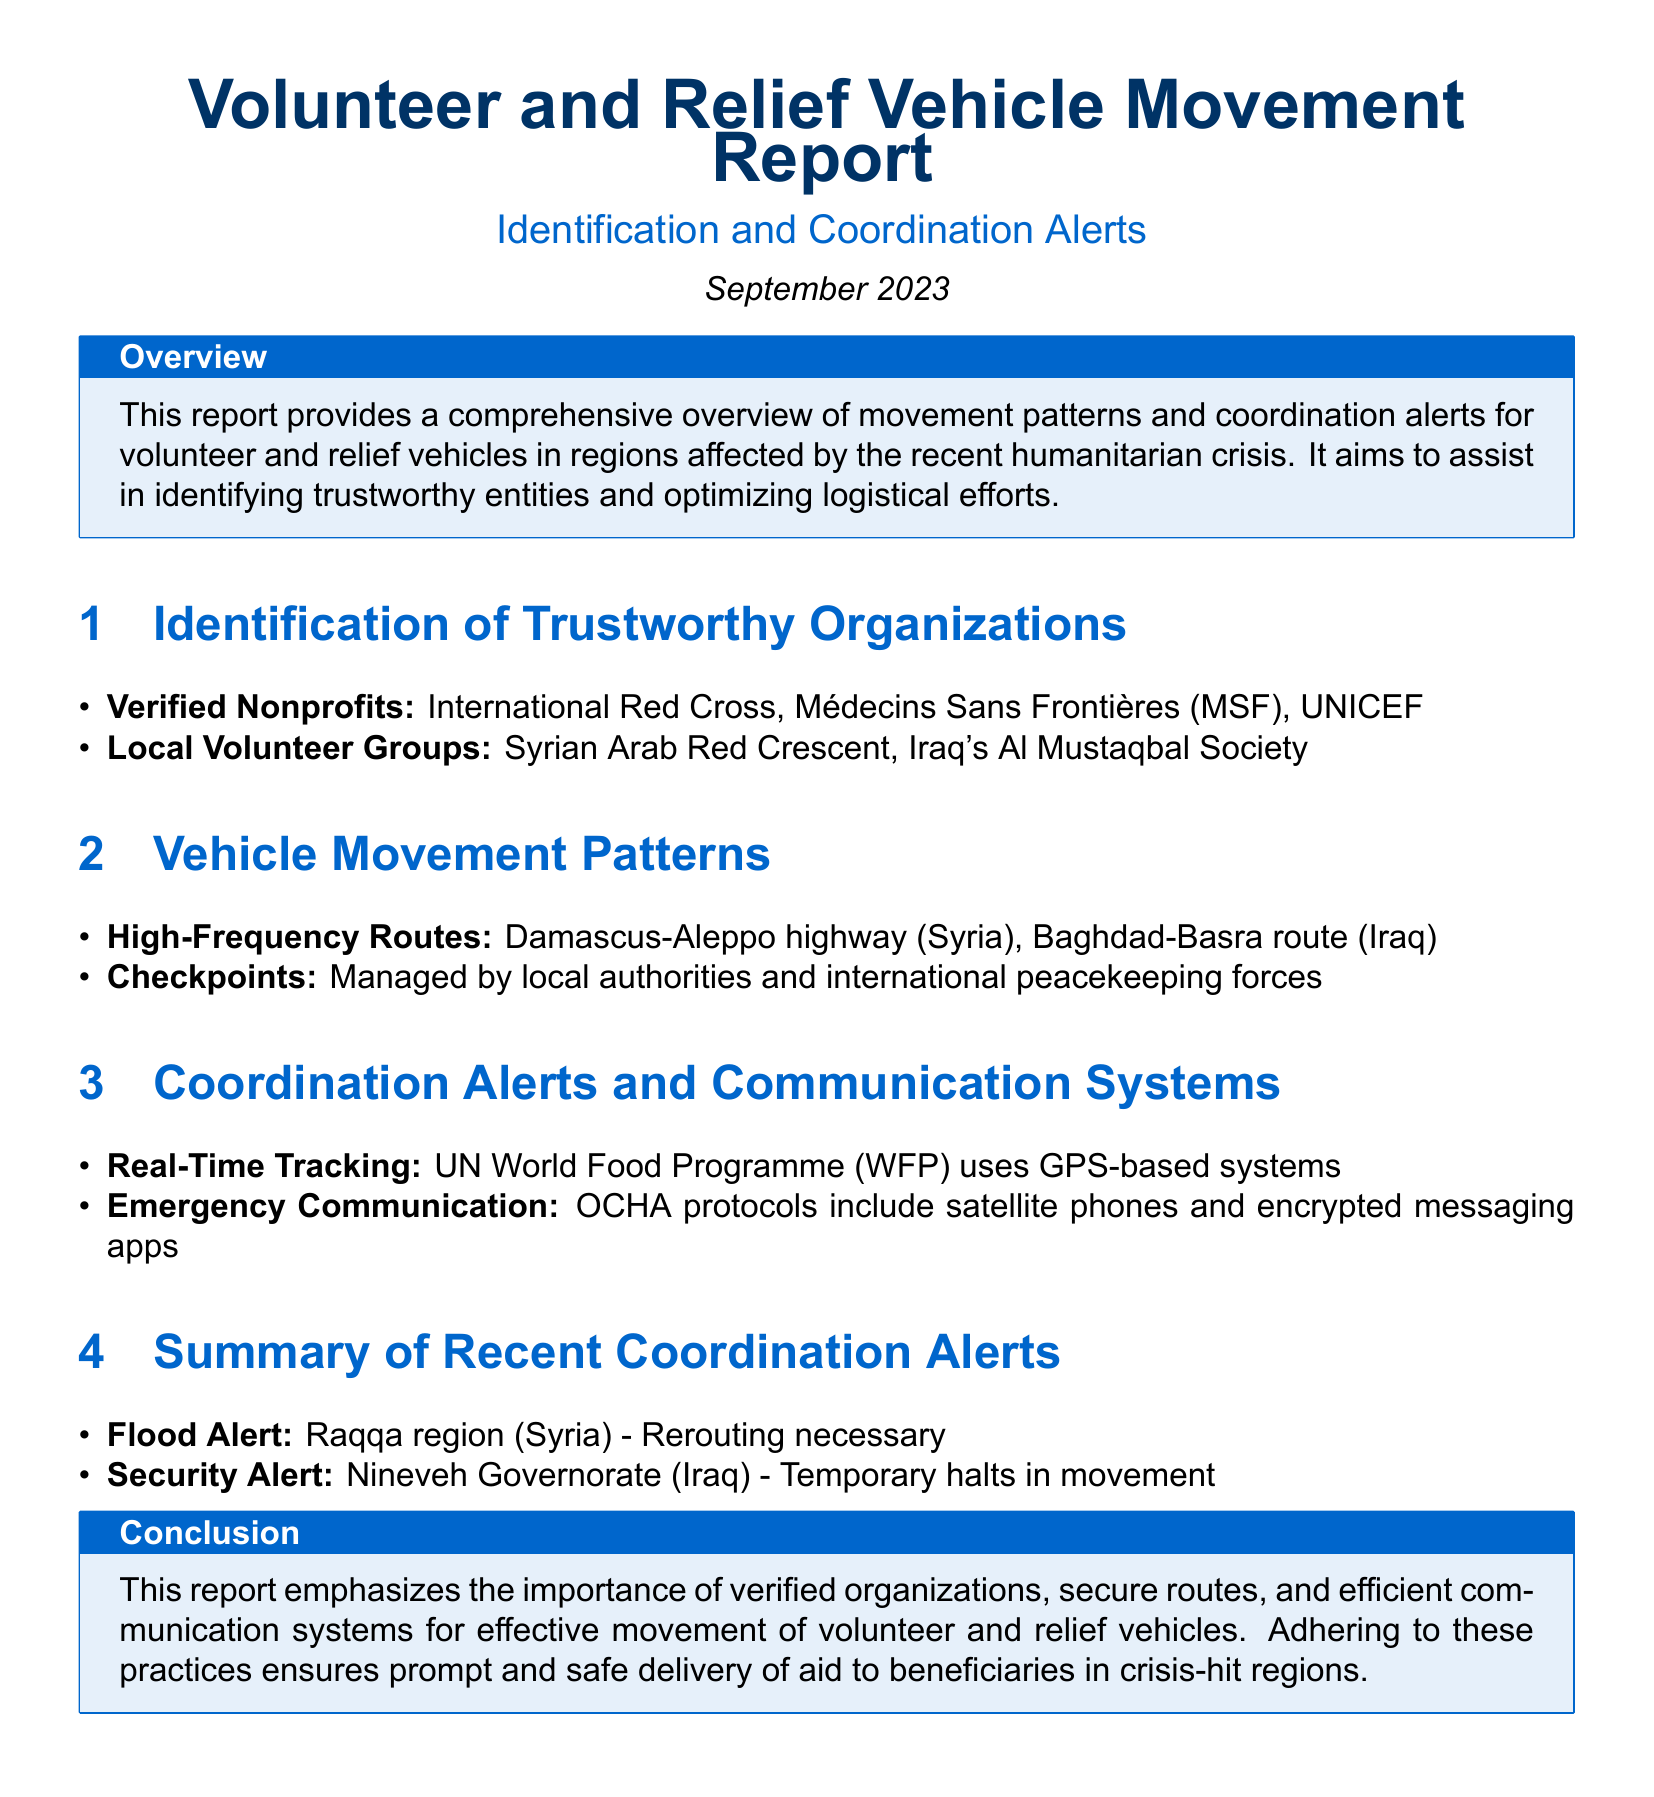What is the title of the report? The title of the report is found at the beginning of the document and indicates its focus on volunteer and relief vehicle movement.
Answer: Volunteer and Relief Vehicle Movement Report Which organizations are listed as verified nonprofits? The section identifies specific nonprofits that have been verified, including well-known humanitarian organizations in the aid sector.
Answer: International Red Cross, Médecins Sans Frontières (MSF), UNICEF What are the high-frequency routes mentioned? The report outlines specific routes that experience regular volunteer and relief vehicle movement, which are crucial for aid distribution.
Answer: Damascus-Aleppo highway, Baghdad-Basra route What communication system does the UN WFP use? The document specifies the tracking method used by the UN WFP, highlighting the technology employed for real-time vehicle location.
Answer: GPS-based systems What alert was issued for the Raqqa region? The report summarizes important alerts, and this specific location was mentioned concerning a weather-related issue that affects transport.
Answer: Flood Alert What is a reason for temporary halts in movement? The document mentions specific circumstances impacting vehicle movement, emphasizing safety and security factors in certain regions.
Answer: Security Alert Which local volunteer group is mentioned? The report lists local organizations aiding in relief efforts, emphasizing their importance in the humanitarian response.
Answer: Syrian Arab Red Crescent What is the purpose of this report? The overview section provides insight into the report's primary objective concerning vehicle movement and coordination in crisis areas.
Answer: Assist in identifying trustworthy entities and optimizing logistical efforts Which protocol includes satellite phones? The communication methods used during emergencies are outlined in the report, detailing specific protocols for reliable communication.
Answer: OCHA protocols 